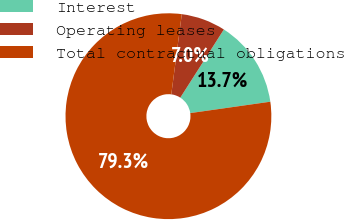<chart> <loc_0><loc_0><loc_500><loc_500><pie_chart><fcel>Interest<fcel>Operating leases<fcel>Total contractual obligations<nl><fcel>13.7%<fcel>6.98%<fcel>79.32%<nl></chart> 